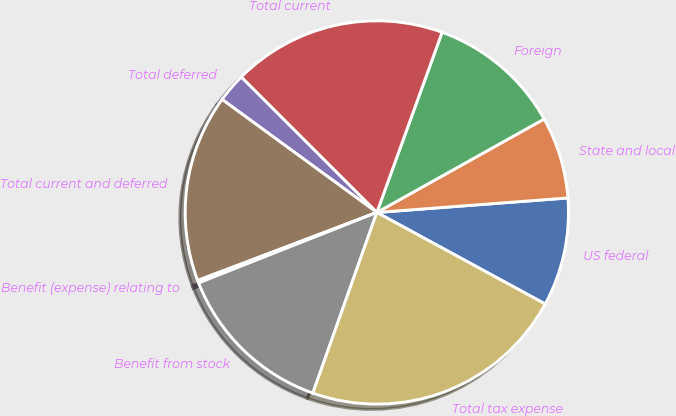<chart> <loc_0><loc_0><loc_500><loc_500><pie_chart><fcel>US federal<fcel>State and local<fcel>Foreign<fcel>Total current<fcel>Total deferred<fcel>Total current and deferred<fcel>Benefit (expense) relating to<fcel>Benefit from stock<fcel>Total tax expense<nl><fcel>9.13%<fcel>6.9%<fcel>11.36%<fcel>18.04%<fcel>2.45%<fcel>15.81%<fcel>0.22%<fcel>13.59%<fcel>22.49%<nl></chart> 